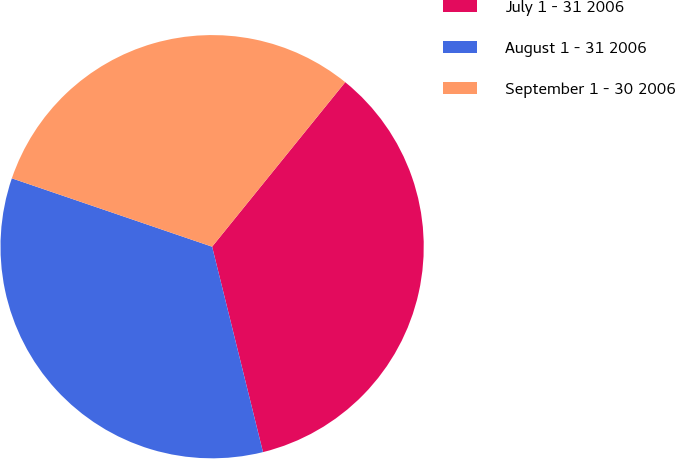Convert chart. <chart><loc_0><loc_0><loc_500><loc_500><pie_chart><fcel>July 1 - 31 2006<fcel>August 1 - 31 2006<fcel>September 1 - 30 2006<nl><fcel>35.31%<fcel>34.1%<fcel>30.59%<nl></chart> 